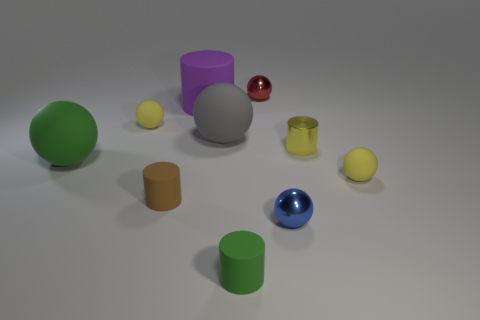Subtract all red cylinders. How many yellow spheres are left? 2 Subtract all big spheres. How many spheres are left? 4 Subtract all blue balls. How many balls are left? 5 Subtract 3 spheres. How many spheres are left? 3 Subtract all balls. How many objects are left? 4 Add 7 big purple cylinders. How many big purple cylinders are left? 8 Add 6 big gray matte spheres. How many big gray matte spheres exist? 7 Subtract 0 red cylinders. How many objects are left? 10 Subtract all blue cylinders. Subtract all green spheres. How many cylinders are left? 4 Subtract all big matte objects. Subtract all small brown shiny things. How many objects are left? 7 